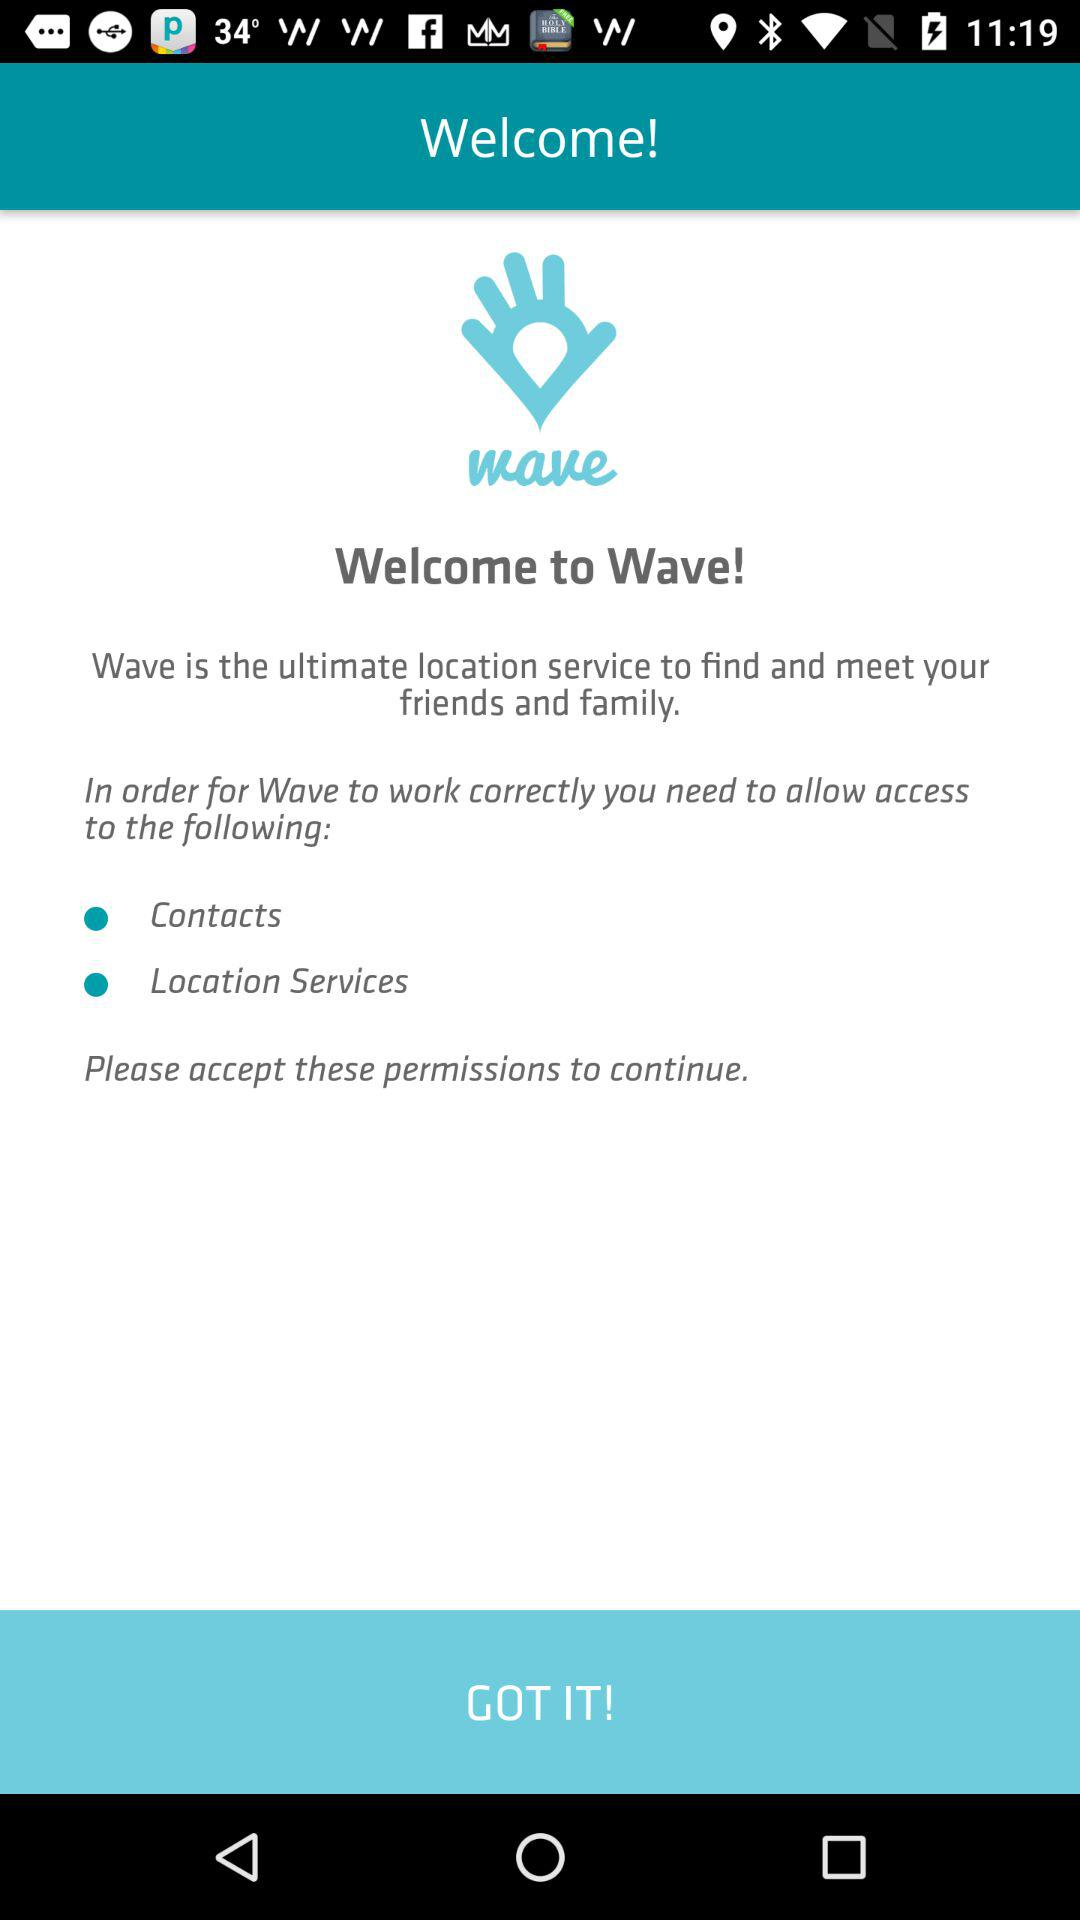What is the app name? The app name is "Wave". 